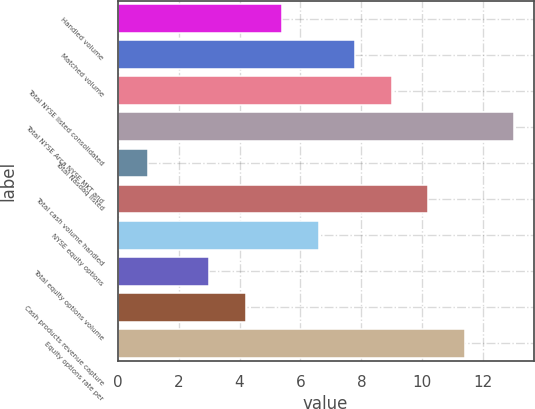<chart> <loc_0><loc_0><loc_500><loc_500><bar_chart><fcel>Handled volume<fcel>Matched volume<fcel>Total NYSE listed consolidated<fcel>Total NYSE Arca NYSE MKT and<fcel>Total Nasdaq listed<fcel>Total cash volume handled<fcel>NYSE equity options<fcel>Total equity options volume<fcel>Cash products revenue capture<fcel>Equity options rate per<nl><fcel>5.4<fcel>7.8<fcel>9<fcel>13<fcel>1<fcel>10.2<fcel>6.6<fcel>3<fcel>4.2<fcel>11.4<nl></chart> 